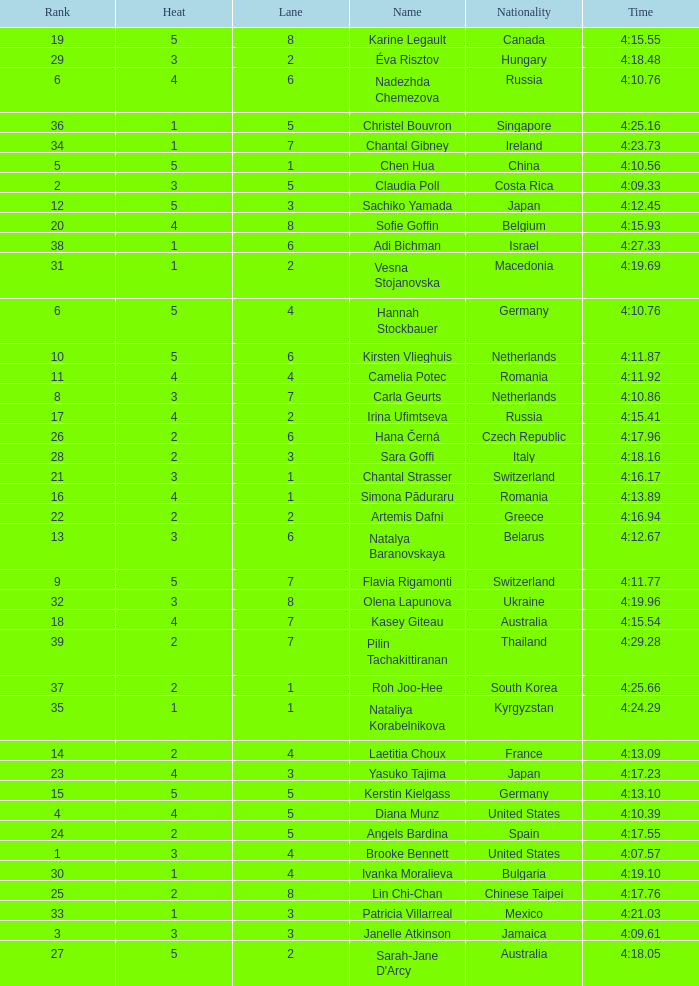Name the least lane for kasey giteau and rank less than 18 None. 